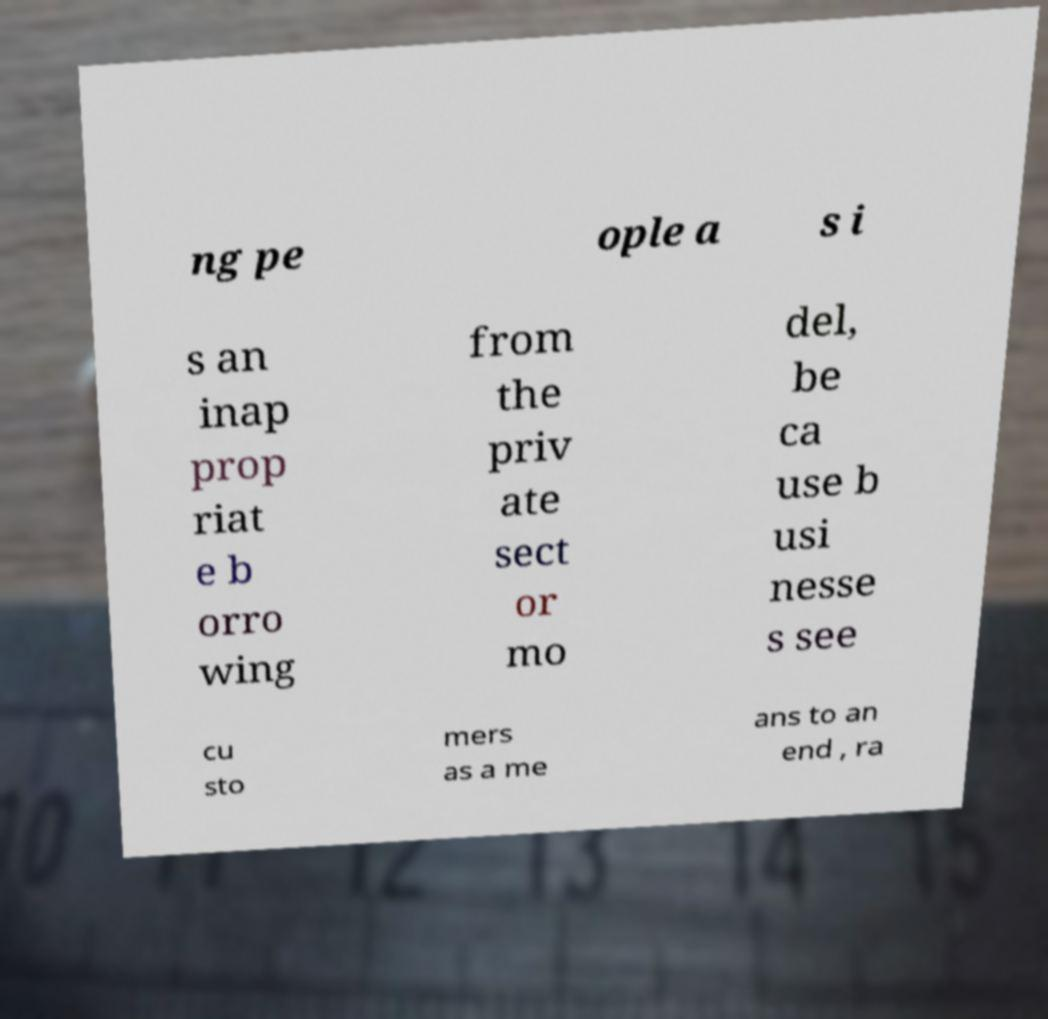Could you extract and type out the text from this image? ng pe ople a s i s an inap prop riat e b orro wing from the priv ate sect or mo del, be ca use b usi nesse s see cu sto mers as a me ans to an end , ra 